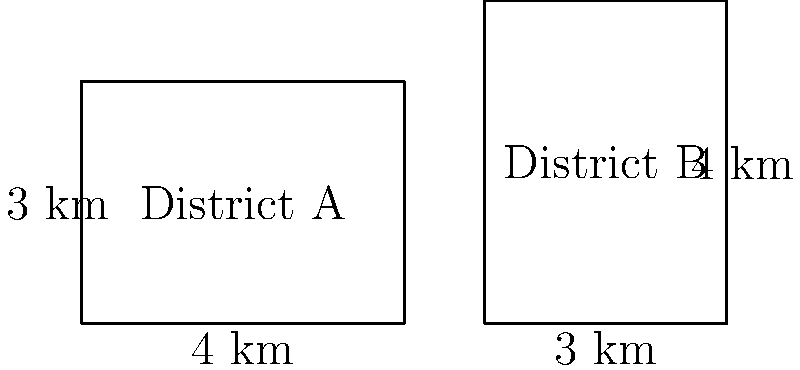In a recent redistricting case, two voting districts are represented by the rectangles shown above. District A has dimensions of 4 km by 3 km, while District B has dimensions of 3 km by 4 km. If a constitutional challenge is raised based on the principle of "one person, one vote," which district would likely be considered to have a larger population density? Assume population is directly proportional to area. To determine which district likely has a larger population density, we need to compare their areas:

1) Calculate the area of District A:
   $A_A = 4 \text{ km} \times 3 \text{ km} = 12 \text{ km}^2$

2) Calculate the area of District B:
   $A_B = 3 \text{ km} \times 4 \text{ km} = 12 \text{ km}^2$

3) Compare the areas:
   $A_A = A_B = 12 \text{ km}^2$

4) Since the areas are equal and population is assumed to be directly proportional to area, the population densities would be the same.

5) In the context of "one person, one vote," neither district would be considered to have a larger population density.

This example illustrates that shape alone doesn't determine population density, and challenges based solely on district shape may not be sufficient for constitutional claims under the "one person, one vote" principle.
Answer: Neither; both districts have equal areas and thus equal population densities. 